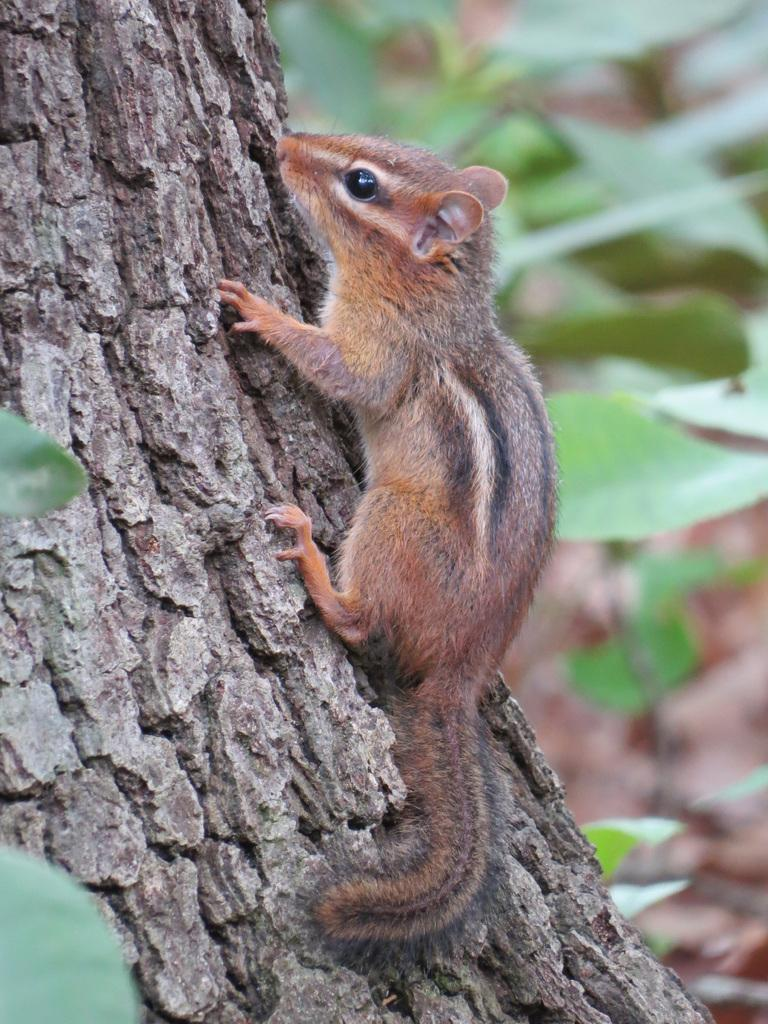What animal is present in the image? There is a squirrel in the image. Where is the squirrel located? The squirrel is on a tree. What is the color of the squirrel? The squirrel is brown in color. What can be seen in the background of the image? There are plants in the background of the image. Where is the faucet located in the image? There is no faucet present in the image. What type of agreement is being made between the squirrel and the tree in the image? There is no agreement being made between the squirrel and the tree in the image; it is a natural scene with a squirrel on a tree. 